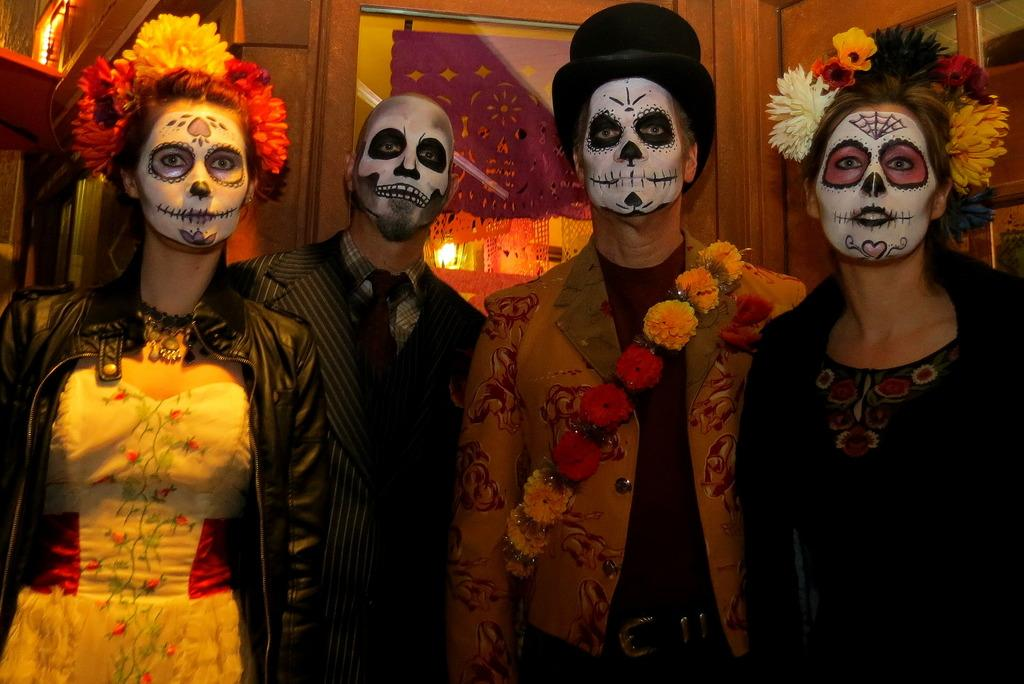How many people are in the image? There is a group of persons standing in the image. What is unique about some of the individuals in the image? Some individuals have paintings on their faces. Can you describe the appearance of one person in the group? There is a person wearing a flower head ware. What type of yoke is being used by the person in the image? There is no yoke present in the image. What kind of bait is being used by the person in the image? There is no fishing or baiting activity depicted in the image. 